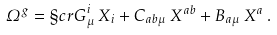<formula> <loc_0><loc_0><loc_500><loc_500>\varOmega ^ { g } = { \S c r G } ^ { i } _ { \mu } \, X _ { i } + C _ { a b \mu } \, X ^ { a b } + B _ { a \mu } \, X ^ { a } \, .</formula> 